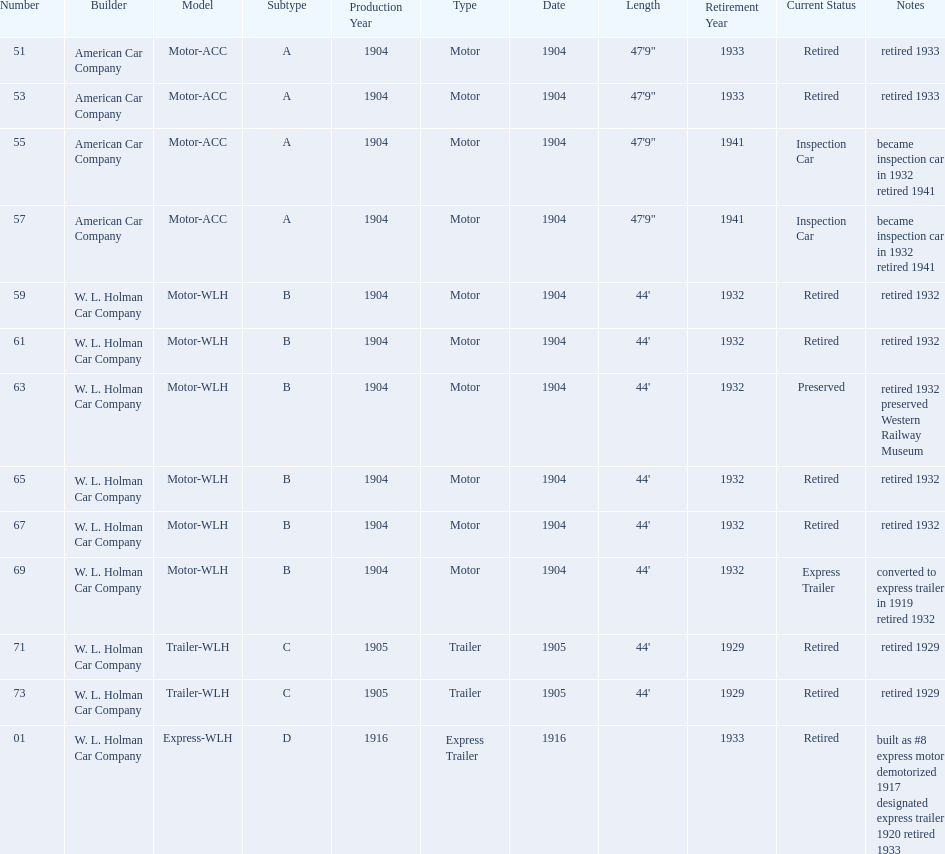Help me parse the entirety of this table. {'header': ['Number', 'Builder', 'Model', 'Subtype', 'Production Year', 'Type', 'Date', 'Length', 'Retirement Year', 'Current Status', 'Notes'], 'rows': [['51', 'American Car Company', 'Motor-ACC', 'A', '1904', 'Motor', '1904', '47\'9"', '1933', 'Retired', 'retired 1933'], ['53', 'American Car Company', 'Motor-ACC', 'A', '1904', 'Motor', '1904', '47\'9"', '1933', 'Retired', 'retired 1933'], ['55', 'American Car Company', 'Motor-ACC', 'A', '1904', 'Motor', '1904', '47\'9"', '1941', 'Inspection Car', 'became inspection car in 1932 retired 1941'], ['57', 'American Car Company', 'Motor-ACC', 'A', '1904', 'Motor', '1904', '47\'9"', '1941', 'Inspection Car', 'became inspection car in 1932 retired 1941'], ['59', 'W. L. Holman Car Company', 'Motor-WLH', 'B', '1904', 'Motor', '1904', "44'", '1932', 'Retired', 'retired 1932'], ['61', 'W. L. Holman Car Company', 'Motor-WLH', 'B', '1904', 'Motor', '1904', "44'", '1932', 'Retired', 'retired 1932'], ['63', 'W. L. Holman Car Company', 'Motor-WLH', 'B', '1904', 'Motor', '1904', "44'", '1932', 'Preserved', 'retired 1932 preserved Western Railway Museum'], ['65', 'W. L. Holman Car Company', 'Motor-WLH', 'B', '1904', 'Motor', '1904', "44'", '1932', 'Retired', 'retired 1932'], ['67', 'W. L. Holman Car Company', 'Motor-WLH', 'B', '1904', 'Motor', '1904', "44'", '1932', 'Retired', 'retired 1932'], ['69', 'W. L. Holman Car Company', 'Motor-WLH', 'B', '1904', 'Motor', '1904', "44'", '1932', 'Express Trailer', 'converted to express trailer in 1919 retired 1932'], ['71', 'W. L. Holman Car Company', 'Trailer-WLH', 'C', '1905', 'Trailer', '1905', "44'", '1929', 'Retired', 'retired 1929'], ['73', 'W. L. Holman Car Company', 'Trailer-WLH', 'C', '1905', 'Trailer', '1905', "44'", '1929', 'Retired', 'retired 1929'], ['01', 'W. L. Holman Car Company', 'Express-WLH', 'D', '1916', 'Express Trailer', '1916', '', '1933', 'Retired', 'built as #8 express motor demotorized 1917 designated express trailer 1920 retired 1933']]} What was the number of cars built by american car company? 4. 